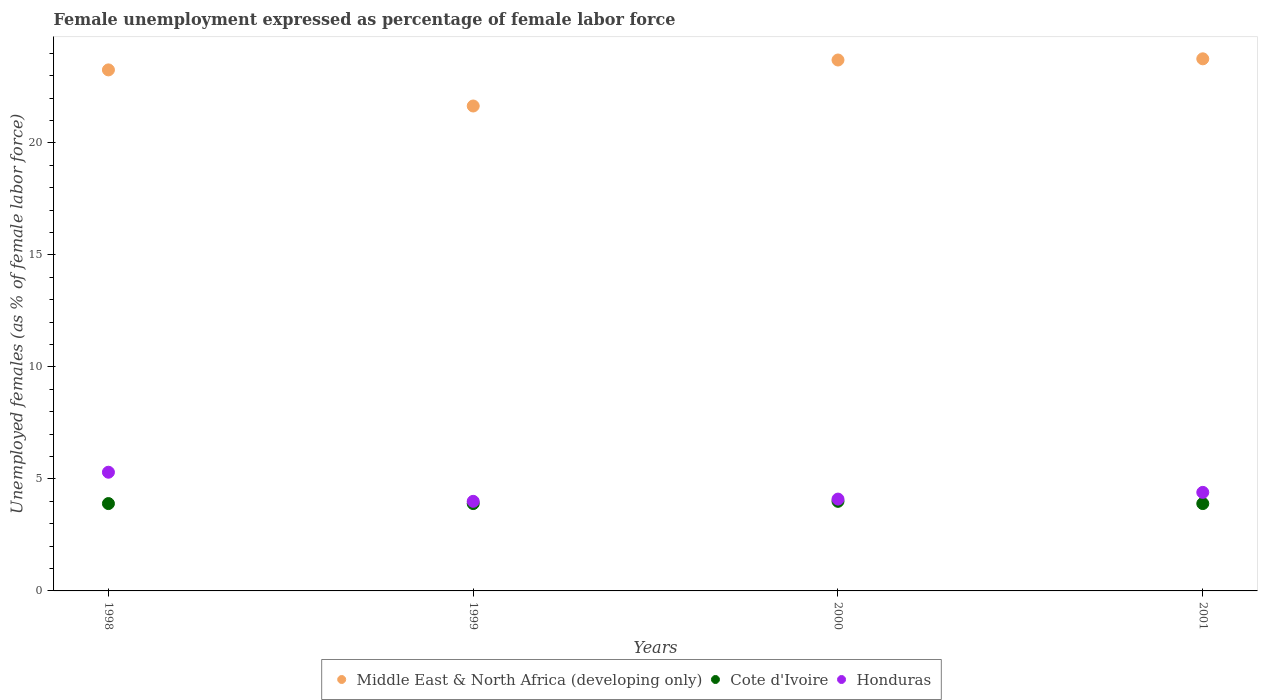What is the unemployment in females in in Honduras in 1998?
Keep it short and to the point. 5.3. Across all years, what is the maximum unemployment in females in in Middle East & North Africa (developing only)?
Provide a succinct answer. 23.76. Across all years, what is the minimum unemployment in females in in Middle East & North Africa (developing only)?
Your answer should be very brief. 21.65. In which year was the unemployment in females in in Honduras maximum?
Provide a succinct answer. 1998. What is the total unemployment in females in in Honduras in the graph?
Provide a succinct answer. 17.8. What is the difference between the unemployment in females in in Honduras in 1998 and that in 2001?
Offer a terse response. 0.9. What is the difference between the unemployment in females in in Middle East & North Africa (developing only) in 1999 and the unemployment in females in in Honduras in 2000?
Provide a succinct answer. 17.55. What is the average unemployment in females in in Honduras per year?
Your answer should be very brief. 4.45. In the year 1999, what is the difference between the unemployment in females in in Cote d'Ivoire and unemployment in females in in Middle East & North Africa (developing only)?
Give a very brief answer. -17.75. In how many years, is the unemployment in females in in Honduras greater than 23 %?
Your answer should be very brief. 0. What is the ratio of the unemployment in females in in Honduras in 1998 to that in 2000?
Keep it short and to the point. 1.29. Is the difference between the unemployment in females in in Cote d'Ivoire in 1999 and 2000 greater than the difference between the unemployment in females in in Middle East & North Africa (developing only) in 1999 and 2000?
Make the answer very short. Yes. What is the difference between the highest and the second highest unemployment in females in in Cote d'Ivoire?
Your response must be concise. 0.1. What is the difference between the highest and the lowest unemployment in females in in Cote d'Ivoire?
Give a very brief answer. 0.1. In how many years, is the unemployment in females in in Cote d'Ivoire greater than the average unemployment in females in in Cote d'Ivoire taken over all years?
Offer a terse response. 1. Is the sum of the unemployment in females in in Middle East & North Africa (developing only) in 1999 and 2000 greater than the maximum unemployment in females in in Honduras across all years?
Make the answer very short. Yes. Is it the case that in every year, the sum of the unemployment in females in in Cote d'Ivoire and unemployment in females in in Middle East & North Africa (developing only)  is greater than the unemployment in females in in Honduras?
Your answer should be very brief. Yes. Does the unemployment in females in in Honduras monotonically increase over the years?
Make the answer very short. No. Is the unemployment in females in in Honduras strictly greater than the unemployment in females in in Cote d'Ivoire over the years?
Make the answer very short. Yes. What is the difference between two consecutive major ticks on the Y-axis?
Ensure brevity in your answer.  5. Are the values on the major ticks of Y-axis written in scientific E-notation?
Keep it short and to the point. No. Does the graph contain grids?
Your response must be concise. No. Where does the legend appear in the graph?
Your response must be concise. Bottom center. How many legend labels are there?
Provide a succinct answer. 3. How are the legend labels stacked?
Give a very brief answer. Horizontal. What is the title of the graph?
Offer a very short reply. Female unemployment expressed as percentage of female labor force. What is the label or title of the Y-axis?
Offer a terse response. Unemployed females (as % of female labor force). What is the Unemployed females (as % of female labor force) in Middle East & North Africa (developing only) in 1998?
Offer a terse response. 23.26. What is the Unemployed females (as % of female labor force) of Cote d'Ivoire in 1998?
Your answer should be compact. 3.9. What is the Unemployed females (as % of female labor force) in Honduras in 1998?
Provide a short and direct response. 5.3. What is the Unemployed females (as % of female labor force) of Middle East & North Africa (developing only) in 1999?
Offer a terse response. 21.65. What is the Unemployed females (as % of female labor force) of Cote d'Ivoire in 1999?
Provide a succinct answer. 3.9. What is the Unemployed females (as % of female labor force) in Honduras in 1999?
Your response must be concise. 4. What is the Unemployed females (as % of female labor force) in Middle East & North Africa (developing only) in 2000?
Keep it short and to the point. 23.71. What is the Unemployed females (as % of female labor force) in Cote d'Ivoire in 2000?
Offer a very short reply. 4. What is the Unemployed females (as % of female labor force) in Honduras in 2000?
Keep it short and to the point. 4.1. What is the Unemployed females (as % of female labor force) in Middle East & North Africa (developing only) in 2001?
Give a very brief answer. 23.76. What is the Unemployed females (as % of female labor force) of Cote d'Ivoire in 2001?
Ensure brevity in your answer.  3.9. What is the Unemployed females (as % of female labor force) of Honduras in 2001?
Your response must be concise. 4.4. Across all years, what is the maximum Unemployed females (as % of female labor force) of Middle East & North Africa (developing only)?
Give a very brief answer. 23.76. Across all years, what is the maximum Unemployed females (as % of female labor force) in Cote d'Ivoire?
Keep it short and to the point. 4. Across all years, what is the maximum Unemployed females (as % of female labor force) in Honduras?
Your answer should be compact. 5.3. Across all years, what is the minimum Unemployed females (as % of female labor force) of Middle East & North Africa (developing only)?
Your answer should be very brief. 21.65. Across all years, what is the minimum Unemployed females (as % of female labor force) of Cote d'Ivoire?
Your answer should be compact. 3.9. What is the total Unemployed females (as % of female labor force) in Middle East & North Africa (developing only) in the graph?
Offer a terse response. 92.38. What is the total Unemployed females (as % of female labor force) of Honduras in the graph?
Your answer should be very brief. 17.8. What is the difference between the Unemployed females (as % of female labor force) in Middle East & North Africa (developing only) in 1998 and that in 1999?
Keep it short and to the point. 1.61. What is the difference between the Unemployed females (as % of female labor force) of Middle East & North Africa (developing only) in 1998 and that in 2000?
Your answer should be compact. -0.44. What is the difference between the Unemployed females (as % of female labor force) of Cote d'Ivoire in 1998 and that in 2000?
Your response must be concise. -0.1. What is the difference between the Unemployed females (as % of female labor force) of Honduras in 1998 and that in 2000?
Provide a succinct answer. 1.2. What is the difference between the Unemployed females (as % of female labor force) in Middle East & North Africa (developing only) in 1998 and that in 2001?
Keep it short and to the point. -0.49. What is the difference between the Unemployed females (as % of female labor force) in Middle East & North Africa (developing only) in 1999 and that in 2000?
Make the answer very short. -2.05. What is the difference between the Unemployed females (as % of female labor force) in Cote d'Ivoire in 1999 and that in 2000?
Provide a succinct answer. -0.1. What is the difference between the Unemployed females (as % of female labor force) in Middle East & North Africa (developing only) in 1999 and that in 2001?
Offer a very short reply. -2.11. What is the difference between the Unemployed females (as % of female labor force) of Middle East & North Africa (developing only) in 2000 and that in 2001?
Keep it short and to the point. -0.05. What is the difference between the Unemployed females (as % of female labor force) of Honduras in 2000 and that in 2001?
Ensure brevity in your answer.  -0.3. What is the difference between the Unemployed females (as % of female labor force) of Middle East & North Africa (developing only) in 1998 and the Unemployed females (as % of female labor force) of Cote d'Ivoire in 1999?
Offer a terse response. 19.36. What is the difference between the Unemployed females (as % of female labor force) of Middle East & North Africa (developing only) in 1998 and the Unemployed females (as % of female labor force) of Honduras in 1999?
Offer a very short reply. 19.26. What is the difference between the Unemployed females (as % of female labor force) of Middle East & North Africa (developing only) in 1998 and the Unemployed females (as % of female labor force) of Cote d'Ivoire in 2000?
Your response must be concise. 19.26. What is the difference between the Unemployed females (as % of female labor force) of Middle East & North Africa (developing only) in 1998 and the Unemployed females (as % of female labor force) of Honduras in 2000?
Your response must be concise. 19.16. What is the difference between the Unemployed females (as % of female labor force) of Cote d'Ivoire in 1998 and the Unemployed females (as % of female labor force) of Honduras in 2000?
Keep it short and to the point. -0.2. What is the difference between the Unemployed females (as % of female labor force) in Middle East & North Africa (developing only) in 1998 and the Unemployed females (as % of female labor force) in Cote d'Ivoire in 2001?
Your answer should be compact. 19.36. What is the difference between the Unemployed females (as % of female labor force) in Middle East & North Africa (developing only) in 1998 and the Unemployed females (as % of female labor force) in Honduras in 2001?
Keep it short and to the point. 18.86. What is the difference between the Unemployed females (as % of female labor force) in Cote d'Ivoire in 1998 and the Unemployed females (as % of female labor force) in Honduras in 2001?
Give a very brief answer. -0.5. What is the difference between the Unemployed females (as % of female labor force) in Middle East & North Africa (developing only) in 1999 and the Unemployed females (as % of female labor force) in Cote d'Ivoire in 2000?
Give a very brief answer. 17.65. What is the difference between the Unemployed females (as % of female labor force) of Middle East & North Africa (developing only) in 1999 and the Unemployed females (as % of female labor force) of Honduras in 2000?
Your response must be concise. 17.55. What is the difference between the Unemployed females (as % of female labor force) in Middle East & North Africa (developing only) in 1999 and the Unemployed females (as % of female labor force) in Cote d'Ivoire in 2001?
Your response must be concise. 17.75. What is the difference between the Unemployed females (as % of female labor force) of Middle East & North Africa (developing only) in 1999 and the Unemployed females (as % of female labor force) of Honduras in 2001?
Your answer should be compact. 17.25. What is the difference between the Unemployed females (as % of female labor force) of Middle East & North Africa (developing only) in 2000 and the Unemployed females (as % of female labor force) of Cote d'Ivoire in 2001?
Your answer should be compact. 19.81. What is the difference between the Unemployed females (as % of female labor force) in Middle East & North Africa (developing only) in 2000 and the Unemployed females (as % of female labor force) in Honduras in 2001?
Your answer should be compact. 19.31. What is the average Unemployed females (as % of female labor force) of Middle East & North Africa (developing only) per year?
Offer a terse response. 23.09. What is the average Unemployed females (as % of female labor force) in Cote d'Ivoire per year?
Provide a short and direct response. 3.92. What is the average Unemployed females (as % of female labor force) in Honduras per year?
Offer a terse response. 4.45. In the year 1998, what is the difference between the Unemployed females (as % of female labor force) of Middle East & North Africa (developing only) and Unemployed females (as % of female labor force) of Cote d'Ivoire?
Keep it short and to the point. 19.36. In the year 1998, what is the difference between the Unemployed females (as % of female labor force) in Middle East & North Africa (developing only) and Unemployed females (as % of female labor force) in Honduras?
Make the answer very short. 17.96. In the year 1998, what is the difference between the Unemployed females (as % of female labor force) in Cote d'Ivoire and Unemployed females (as % of female labor force) in Honduras?
Offer a very short reply. -1.4. In the year 1999, what is the difference between the Unemployed females (as % of female labor force) of Middle East & North Africa (developing only) and Unemployed females (as % of female labor force) of Cote d'Ivoire?
Your response must be concise. 17.75. In the year 1999, what is the difference between the Unemployed females (as % of female labor force) of Middle East & North Africa (developing only) and Unemployed females (as % of female labor force) of Honduras?
Offer a terse response. 17.65. In the year 1999, what is the difference between the Unemployed females (as % of female labor force) in Cote d'Ivoire and Unemployed females (as % of female labor force) in Honduras?
Your response must be concise. -0.1. In the year 2000, what is the difference between the Unemployed females (as % of female labor force) of Middle East & North Africa (developing only) and Unemployed females (as % of female labor force) of Cote d'Ivoire?
Your answer should be very brief. 19.71. In the year 2000, what is the difference between the Unemployed females (as % of female labor force) in Middle East & North Africa (developing only) and Unemployed females (as % of female labor force) in Honduras?
Your answer should be very brief. 19.61. In the year 2000, what is the difference between the Unemployed females (as % of female labor force) in Cote d'Ivoire and Unemployed females (as % of female labor force) in Honduras?
Your response must be concise. -0.1. In the year 2001, what is the difference between the Unemployed females (as % of female labor force) of Middle East & North Africa (developing only) and Unemployed females (as % of female labor force) of Cote d'Ivoire?
Offer a terse response. 19.86. In the year 2001, what is the difference between the Unemployed females (as % of female labor force) of Middle East & North Africa (developing only) and Unemployed females (as % of female labor force) of Honduras?
Your answer should be very brief. 19.36. In the year 2001, what is the difference between the Unemployed females (as % of female labor force) in Cote d'Ivoire and Unemployed females (as % of female labor force) in Honduras?
Your response must be concise. -0.5. What is the ratio of the Unemployed females (as % of female labor force) of Middle East & North Africa (developing only) in 1998 to that in 1999?
Provide a succinct answer. 1.07. What is the ratio of the Unemployed females (as % of female labor force) of Cote d'Ivoire in 1998 to that in 1999?
Make the answer very short. 1. What is the ratio of the Unemployed females (as % of female labor force) in Honduras in 1998 to that in 1999?
Give a very brief answer. 1.32. What is the ratio of the Unemployed females (as % of female labor force) of Middle East & North Africa (developing only) in 1998 to that in 2000?
Provide a short and direct response. 0.98. What is the ratio of the Unemployed females (as % of female labor force) in Cote d'Ivoire in 1998 to that in 2000?
Your answer should be very brief. 0.97. What is the ratio of the Unemployed females (as % of female labor force) of Honduras in 1998 to that in 2000?
Your response must be concise. 1.29. What is the ratio of the Unemployed females (as % of female labor force) in Middle East & North Africa (developing only) in 1998 to that in 2001?
Keep it short and to the point. 0.98. What is the ratio of the Unemployed females (as % of female labor force) in Cote d'Ivoire in 1998 to that in 2001?
Provide a succinct answer. 1. What is the ratio of the Unemployed females (as % of female labor force) of Honduras in 1998 to that in 2001?
Ensure brevity in your answer.  1.2. What is the ratio of the Unemployed females (as % of female labor force) of Middle East & North Africa (developing only) in 1999 to that in 2000?
Provide a short and direct response. 0.91. What is the ratio of the Unemployed females (as % of female labor force) in Honduras in 1999 to that in 2000?
Ensure brevity in your answer.  0.98. What is the ratio of the Unemployed females (as % of female labor force) in Middle East & North Africa (developing only) in 1999 to that in 2001?
Make the answer very short. 0.91. What is the ratio of the Unemployed females (as % of female labor force) in Honduras in 1999 to that in 2001?
Offer a very short reply. 0.91. What is the ratio of the Unemployed females (as % of female labor force) of Middle East & North Africa (developing only) in 2000 to that in 2001?
Offer a terse response. 1. What is the ratio of the Unemployed females (as % of female labor force) of Cote d'Ivoire in 2000 to that in 2001?
Your answer should be compact. 1.03. What is the ratio of the Unemployed females (as % of female labor force) in Honduras in 2000 to that in 2001?
Provide a short and direct response. 0.93. What is the difference between the highest and the second highest Unemployed females (as % of female labor force) of Middle East & North Africa (developing only)?
Provide a succinct answer. 0.05. What is the difference between the highest and the lowest Unemployed females (as % of female labor force) of Middle East & North Africa (developing only)?
Your response must be concise. 2.11. 